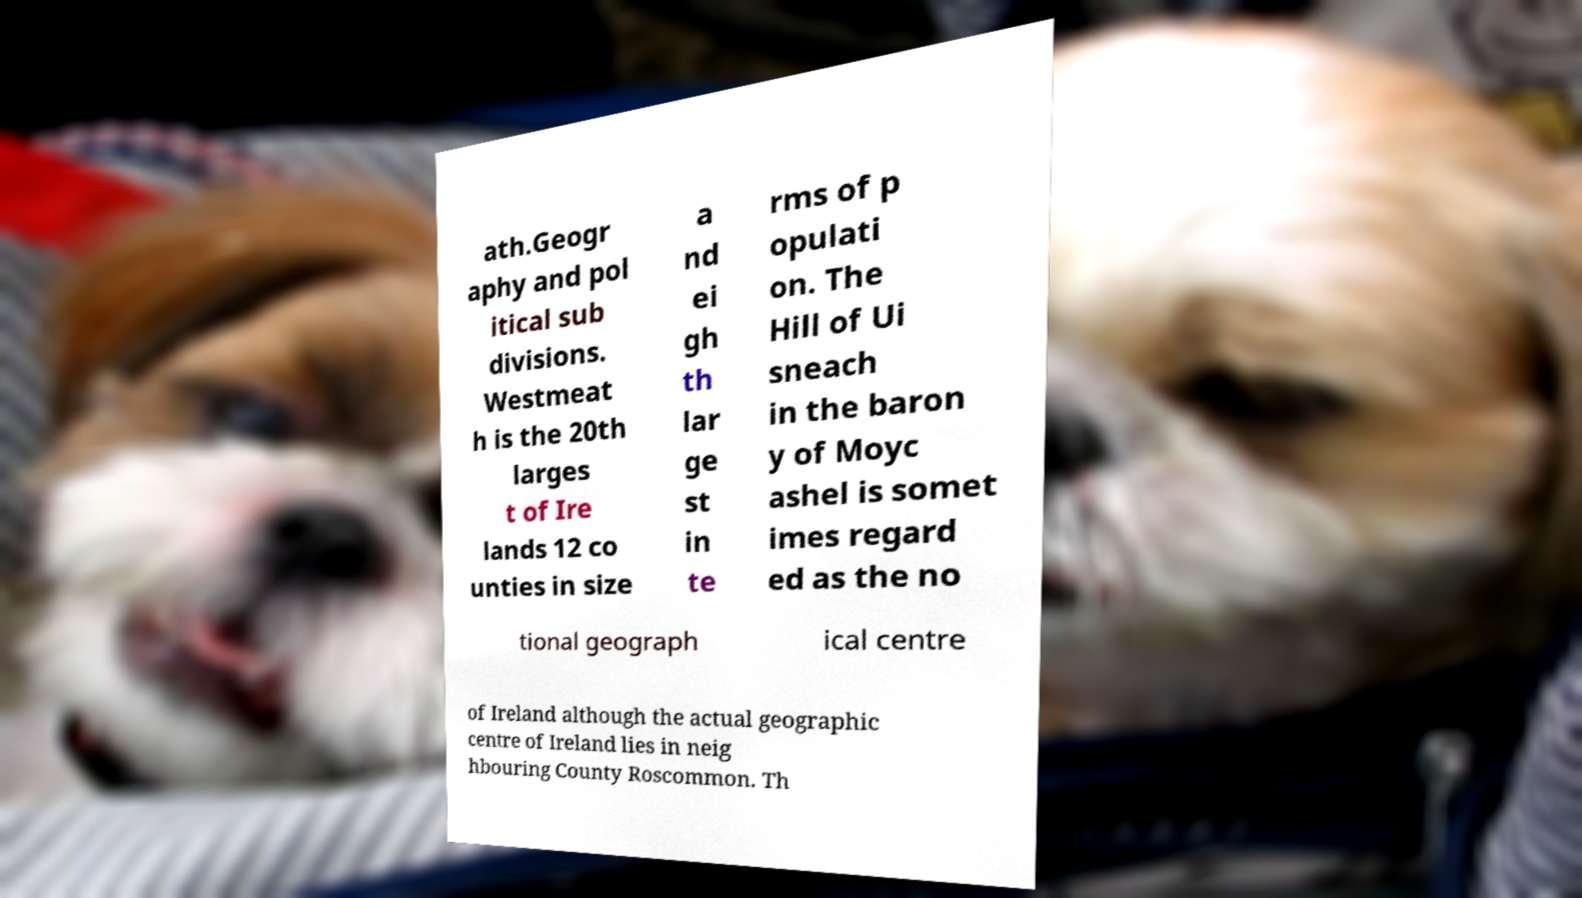I need the written content from this picture converted into text. Can you do that? ath.Geogr aphy and pol itical sub divisions. Westmeat h is the 20th larges t of Ire lands 12 co unties in size a nd ei gh th lar ge st in te rms of p opulati on. The Hill of Ui sneach in the baron y of Moyc ashel is somet imes regard ed as the no tional geograph ical centre of Ireland although the actual geographic centre of Ireland lies in neig hbouring County Roscommon. Th 